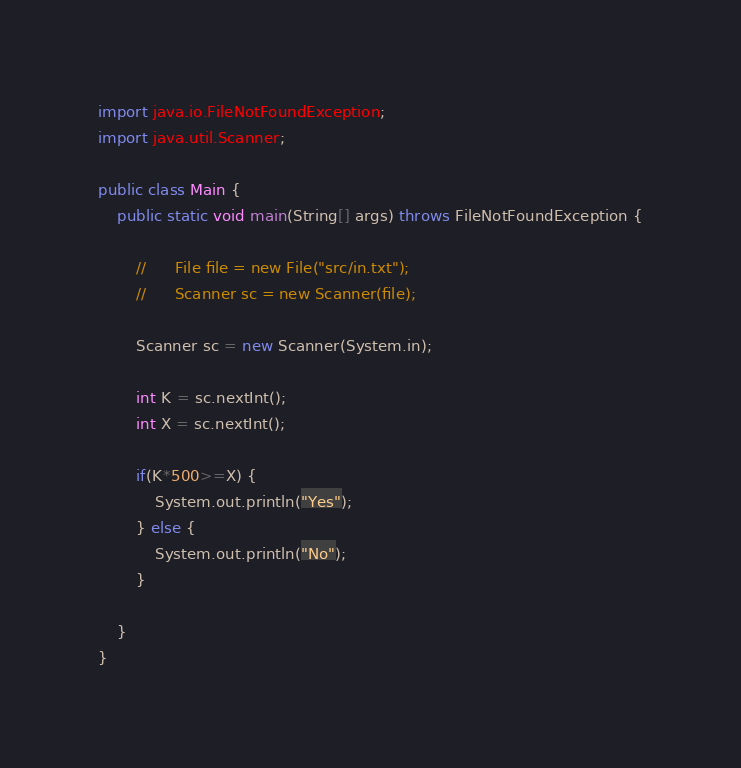<code> <loc_0><loc_0><loc_500><loc_500><_Java_>import java.io.FileNotFoundException;
import java.util.Scanner;

public class Main {
	public static void main(String[] args) throws FileNotFoundException {

		//    	File file = new File("src/in.txt");
		//    	Scanner sc = new Scanner(file);

		Scanner sc = new Scanner(System.in);

		int K = sc.nextInt();
		int X = sc.nextInt();

		if(K*500>=X) {
			System.out.println("Yes");
		} else {
			System.out.println("No");
		}

	}
}
</code> 